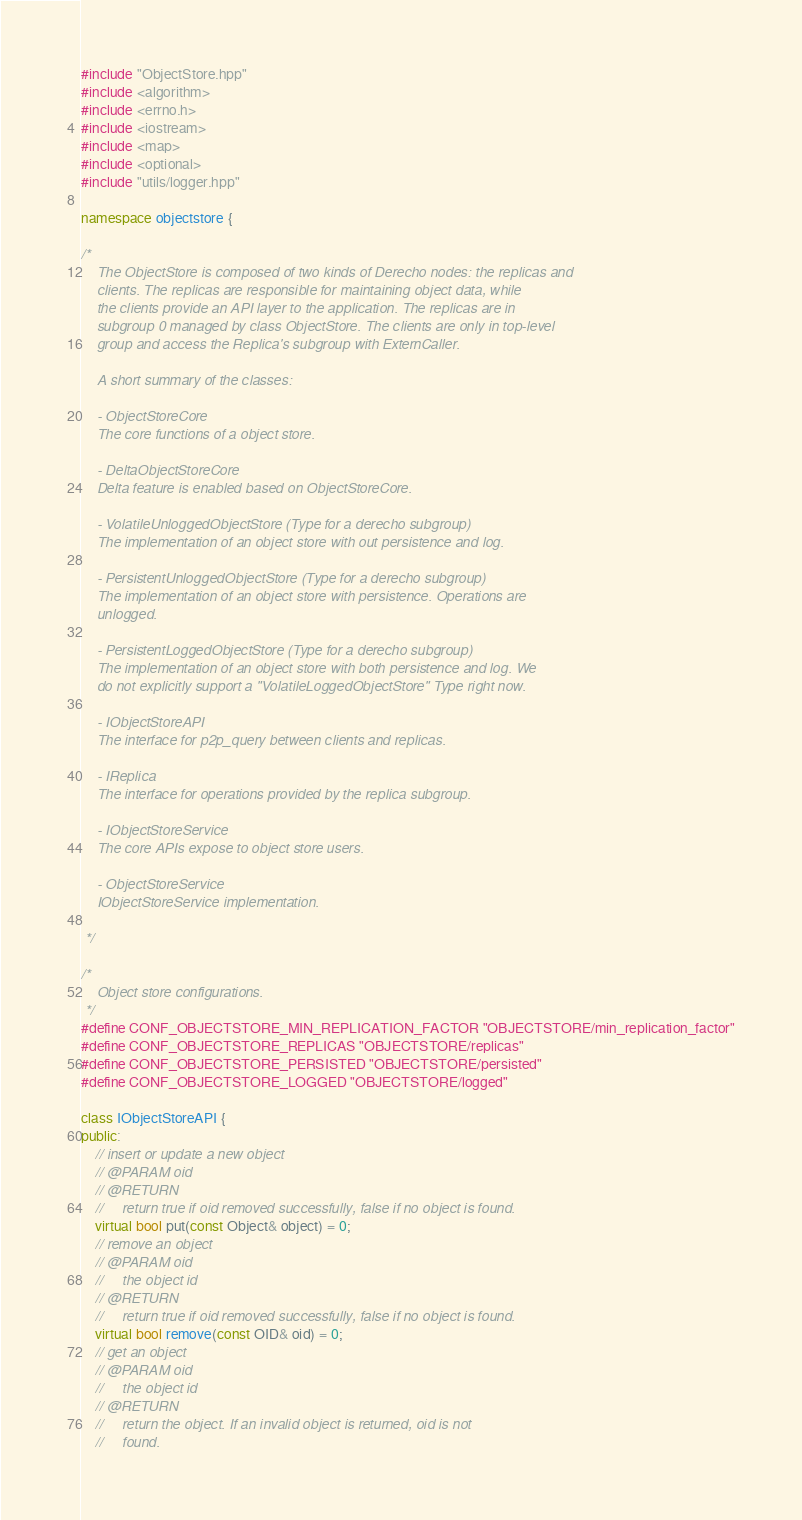<code> <loc_0><loc_0><loc_500><loc_500><_C++_>#include "ObjectStore.hpp"
#include <algorithm>
#include <errno.h>
#include <iostream>
#include <map>
#include <optional>
#include "utils/logger.hpp"

namespace objectstore {

/*
    The ObjectStore is composed of two kinds of Derecho nodes: the replicas and
    clients. The replicas are responsible for maintaining object data, while
    the clients provide an API layer to the application. The replicas are in
    subgroup 0 managed by class ObjectStore. The clients are only in top-level
    group and access the Replica's subgroup with ExternCaller.

    A short summary of the classes:

    - ObjectStoreCore
    The core functions of a object store.

    - DeltaObjectStoreCore
    Delta feature is enabled based on ObjectStoreCore.

    - VolatileUnloggedObjectStore (Type for a derecho subgroup)
    The implementation of an object store with out persistence and log.

    - PersistentUnloggedObjectStore (Type for a derecho subgroup)
    The implementation of an object store with persistence. Operations are
    unlogged.

    - PersistentLoggedObjectStore (Type for a derecho subgroup)
    The implementation of an object store with both persistence and log. We
    do not explicitly support a "VolatileLoggedObjectStore" Type right now.

    - IObjectStoreAPI
    The interface for p2p_query between clients and replicas.

    - IReplica
    The interface for operations provided by the replica subgroup.

    - IObjectStoreService
    The core APIs expose to object store users.

    - ObjectStoreService
    IObjectStoreService implementation.
    
 */

/*
    Object store configurations.
 */
#define CONF_OBJECTSTORE_MIN_REPLICATION_FACTOR "OBJECTSTORE/min_replication_factor"
#define CONF_OBJECTSTORE_REPLICAS "OBJECTSTORE/replicas"
#define CONF_OBJECTSTORE_PERSISTED "OBJECTSTORE/persisted"
#define CONF_OBJECTSTORE_LOGGED "OBJECTSTORE/logged"

class IObjectStoreAPI {
public:
    // insert or update a new object
    // @PARAM oid
    // @RETURN
    //     return true if oid removed successfully, false if no object is found.
    virtual bool put(const Object& object) = 0;
    // remove an object
    // @PARAM oid
    //     the object id
    // @RETURN
    //     return true if oid removed successfully, false if no object is found.
    virtual bool remove(const OID& oid) = 0;
    // get an object
    // @PARAM oid
    //     the object id
    // @RETURN
    //     return the object. If an invalid object is returned, oid is not
    //     found.</code> 